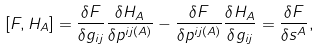<formula> <loc_0><loc_0><loc_500><loc_500>[ F , H _ { A } ] = \frac { \delta F } { \delta g _ { i j } } \frac { \delta H _ { A } } { \delta p ^ { i j ( A ) } } - \frac { \delta F } { \delta p ^ { i j ( A ) } } \frac { \delta H _ { A } } { \delta g _ { i j } } = \frac { \delta F } { \delta s ^ { A } } ,</formula> 